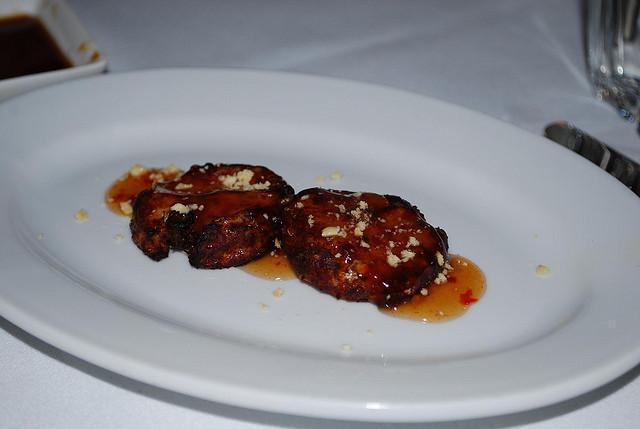How many items on the plate?
Give a very brief answer. 2. How many glasses are in the background?
Give a very brief answer. 1. How many eggs are on the plate?
Give a very brief answer. 0. How many items of food are there?
Give a very brief answer. 2. 